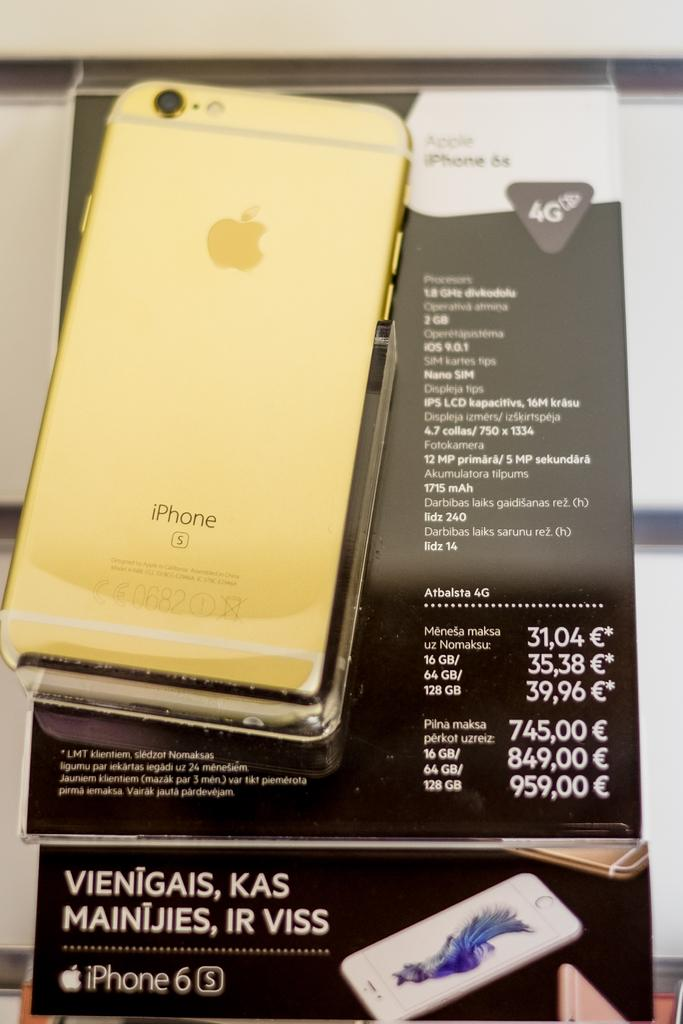<image>
Offer a succinct explanation of the picture presented. A gold colored iPhone6s is for sale in a European country. 